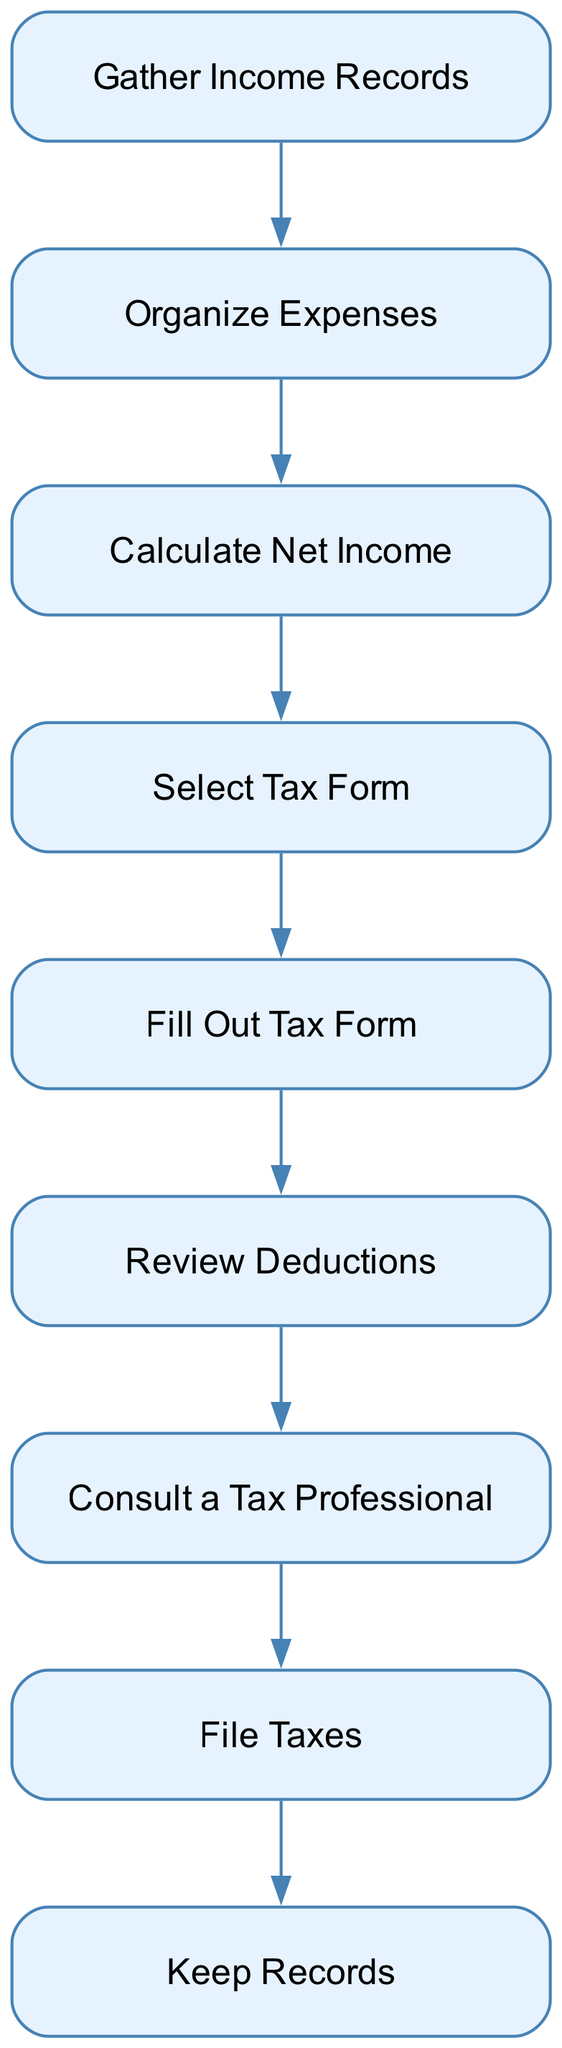What is the first step in the tax preparation process? The first step in the flow chart is "Gather Income Records." This is confirmed by the position of the node at the top of the diagram, indicating its place in the sequence.
Answer: Gather Income Records How many nodes are there in the diagram? Counting each labeled step in the flow chart, there are nine distinct nodes, representing different tasks in the process.
Answer: Nine What is the relationship between "Organize Expenses" and "Calculate Net Income"? "Organize Expenses" precedes "Calculate Net Income" in the flow, indicating that expenses must be organized before calculating net income.
Answer: Organize Expenses comes before Calculate Net Income Which node comes after "Fill Out Tax Form"? The node that comes after "Fill Out Tax Form" is "Review Deductions," as indicated by the directed flow of the diagram.
Answer: Review Deductions What should you do after consulting a tax professional? After "Consult a Tax Professional," the next step is "File Taxes," which follows directly in the sequence of tasks.
Answer: File Taxes Explain the decision-making process if you do not understand the tax form requirements. If you do not understand the tax form requirements, the diagram suggests you should "Consult a Tax Professional." This indicates that professional advice will help clarify the necessary steps and details.
Answer: Consult a Tax Professional What is the last step in the tax preparation process? The last step in the flow chart is "Keep Records," which indicates that after filing taxes, the next task is to store all related documents for reference.
Answer: Keep Records How do the nodes for "Calculate Net Income" and "Select Tax Form" relate? "Calculate Net Income" must be completed before "Select Tax Form" because the calculation provides essential information that influences the form selection. This demonstrates a logical progression in the process.
Answer: Calculate Net Income comes before Select Tax Form What task follows the "Organize Expenses" step? The task that follows "Organize Expenses" is "Calculate Net Income," which directly indicates that after organizing the expenses, the next action is to assess the net income.
Answer: Calculate Net Income 